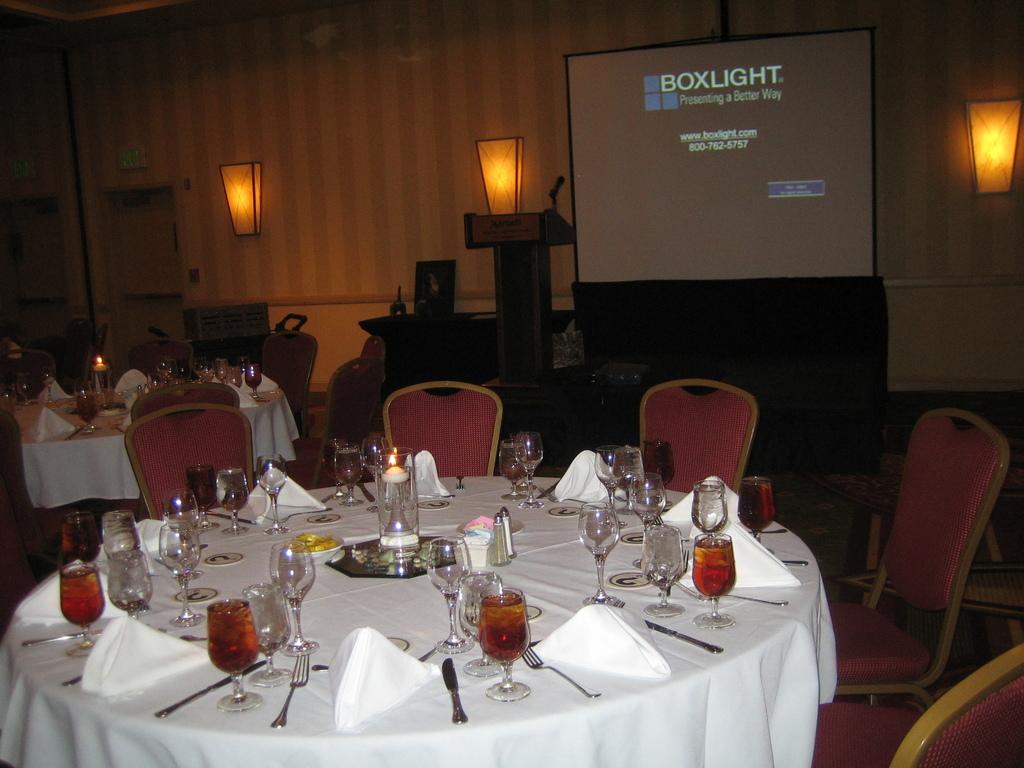What presenting software is being used on the screen?
Keep it short and to the point. Boxlight. Name in the middle of the screen is?
Offer a terse response. Boxlight. 